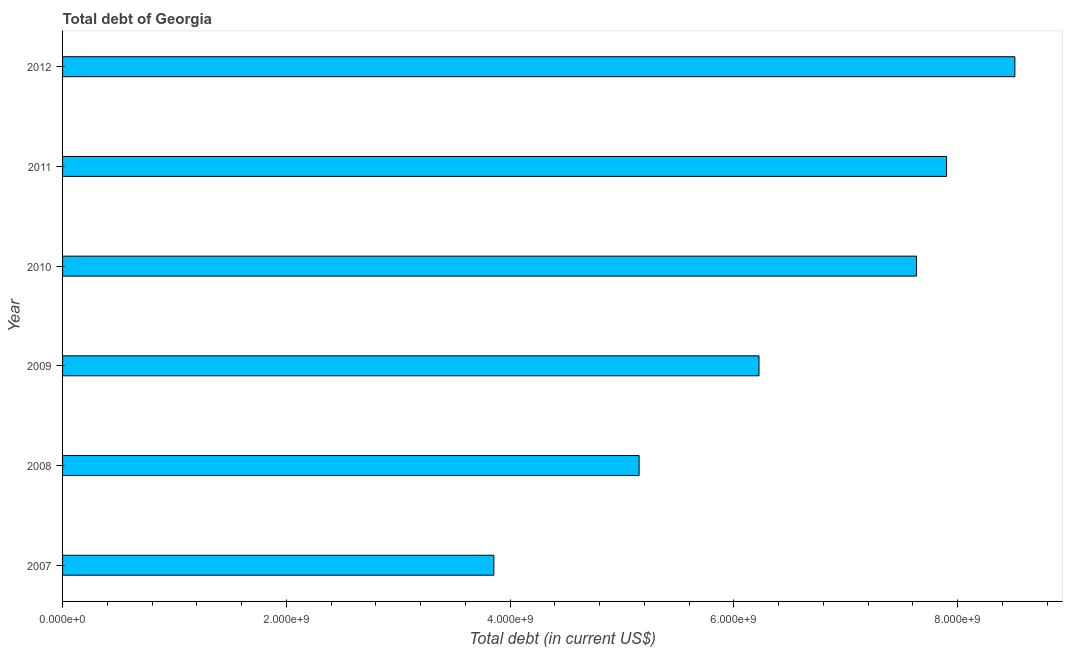Does the graph contain any zero values?
Provide a succinct answer. No. What is the title of the graph?
Give a very brief answer. Total debt of Georgia. What is the label or title of the X-axis?
Ensure brevity in your answer.  Total debt (in current US$). What is the total debt in 2008?
Offer a very short reply. 5.15e+09. Across all years, what is the maximum total debt?
Make the answer very short. 8.51e+09. Across all years, what is the minimum total debt?
Provide a short and direct response. 3.86e+09. In which year was the total debt maximum?
Your answer should be very brief. 2012. What is the sum of the total debt?
Ensure brevity in your answer.  3.93e+1. What is the difference between the total debt in 2007 and 2012?
Your answer should be compact. -4.66e+09. What is the average total debt per year?
Ensure brevity in your answer.  6.55e+09. What is the median total debt?
Your response must be concise. 6.93e+09. In how many years, is the total debt greater than 3600000000 US$?
Make the answer very short. 6. What is the ratio of the total debt in 2007 to that in 2009?
Provide a short and direct response. 0.62. Is the difference between the total debt in 2007 and 2009 greater than the difference between any two years?
Ensure brevity in your answer.  No. What is the difference between the highest and the second highest total debt?
Offer a terse response. 6.10e+08. What is the difference between the highest and the lowest total debt?
Offer a terse response. 4.66e+09. How many years are there in the graph?
Your answer should be very brief. 6. What is the difference between two consecutive major ticks on the X-axis?
Provide a short and direct response. 2.00e+09. What is the Total debt (in current US$) in 2007?
Your response must be concise. 3.86e+09. What is the Total debt (in current US$) of 2008?
Make the answer very short. 5.15e+09. What is the Total debt (in current US$) in 2009?
Give a very brief answer. 6.23e+09. What is the Total debt (in current US$) of 2010?
Make the answer very short. 7.63e+09. What is the Total debt (in current US$) in 2011?
Keep it short and to the point. 7.90e+09. What is the Total debt (in current US$) of 2012?
Make the answer very short. 8.51e+09. What is the difference between the Total debt (in current US$) in 2007 and 2008?
Your response must be concise. -1.30e+09. What is the difference between the Total debt (in current US$) in 2007 and 2009?
Provide a succinct answer. -2.37e+09. What is the difference between the Total debt (in current US$) in 2007 and 2010?
Give a very brief answer. -3.78e+09. What is the difference between the Total debt (in current US$) in 2007 and 2011?
Your answer should be compact. -4.05e+09. What is the difference between the Total debt (in current US$) in 2007 and 2012?
Provide a succinct answer. -4.66e+09. What is the difference between the Total debt (in current US$) in 2008 and 2009?
Provide a succinct answer. -1.07e+09. What is the difference between the Total debt (in current US$) in 2008 and 2010?
Make the answer very short. -2.48e+09. What is the difference between the Total debt (in current US$) in 2008 and 2011?
Make the answer very short. -2.75e+09. What is the difference between the Total debt (in current US$) in 2008 and 2012?
Provide a succinct answer. -3.36e+09. What is the difference between the Total debt (in current US$) in 2009 and 2010?
Your response must be concise. -1.41e+09. What is the difference between the Total debt (in current US$) in 2009 and 2011?
Ensure brevity in your answer.  -1.68e+09. What is the difference between the Total debt (in current US$) in 2009 and 2012?
Offer a very short reply. -2.29e+09. What is the difference between the Total debt (in current US$) in 2010 and 2011?
Give a very brief answer. -2.68e+08. What is the difference between the Total debt (in current US$) in 2010 and 2012?
Offer a terse response. -8.79e+08. What is the difference between the Total debt (in current US$) in 2011 and 2012?
Make the answer very short. -6.10e+08. What is the ratio of the Total debt (in current US$) in 2007 to that in 2008?
Offer a very short reply. 0.75. What is the ratio of the Total debt (in current US$) in 2007 to that in 2009?
Offer a very short reply. 0.62. What is the ratio of the Total debt (in current US$) in 2007 to that in 2010?
Offer a very short reply. 0.51. What is the ratio of the Total debt (in current US$) in 2007 to that in 2011?
Your answer should be very brief. 0.49. What is the ratio of the Total debt (in current US$) in 2007 to that in 2012?
Provide a short and direct response. 0.45. What is the ratio of the Total debt (in current US$) in 2008 to that in 2009?
Offer a terse response. 0.83. What is the ratio of the Total debt (in current US$) in 2008 to that in 2010?
Your answer should be compact. 0.68. What is the ratio of the Total debt (in current US$) in 2008 to that in 2011?
Your answer should be very brief. 0.65. What is the ratio of the Total debt (in current US$) in 2008 to that in 2012?
Your answer should be compact. 0.6. What is the ratio of the Total debt (in current US$) in 2009 to that in 2010?
Make the answer very short. 0.82. What is the ratio of the Total debt (in current US$) in 2009 to that in 2011?
Your answer should be very brief. 0.79. What is the ratio of the Total debt (in current US$) in 2009 to that in 2012?
Ensure brevity in your answer.  0.73. What is the ratio of the Total debt (in current US$) in 2010 to that in 2011?
Your answer should be compact. 0.97. What is the ratio of the Total debt (in current US$) in 2010 to that in 2012?
Provide a succinct answer. 0.9. What is the ratio of the Total debt (in current US$) in 2011 to that in 2012?
Offer a very short reply. 0.93. 